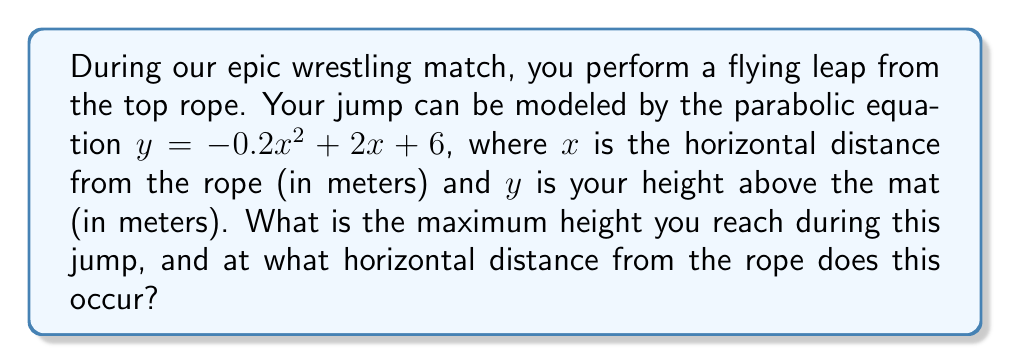Give your solution to this math problem. To solve this problem, we'll follow these steps:

1) The parabolic equation is in the form $y = ax^2 + bx + c$, where $a = -0.2$, $b = 2$, and $c = 6$.

2) For a parabola, the x-coordinate of the vertex represents the point where the maximum height occurs. We can find this using the formula: $x = -\frac{b}{2a}$

3) Let's calculate:
   $x = -\frac{2}{2(-0.2)} = -\frac{2}{-0.4} = 5$ meters

4) To find the maximum height, we substitute this x-value back into the original equation:

   $y = -0.2(5)^2 + 2(5) + 6$
   $= -0.2(25) + 10 + 6$
   $= -5 + 10 + 6$
   $= 11$ meters

5) Therefore, the maximum height is 11 meters, occurring 5 meters horizontally from the rope.
Answer: Maximum height: 11 m; Distance from rope: 5 m 